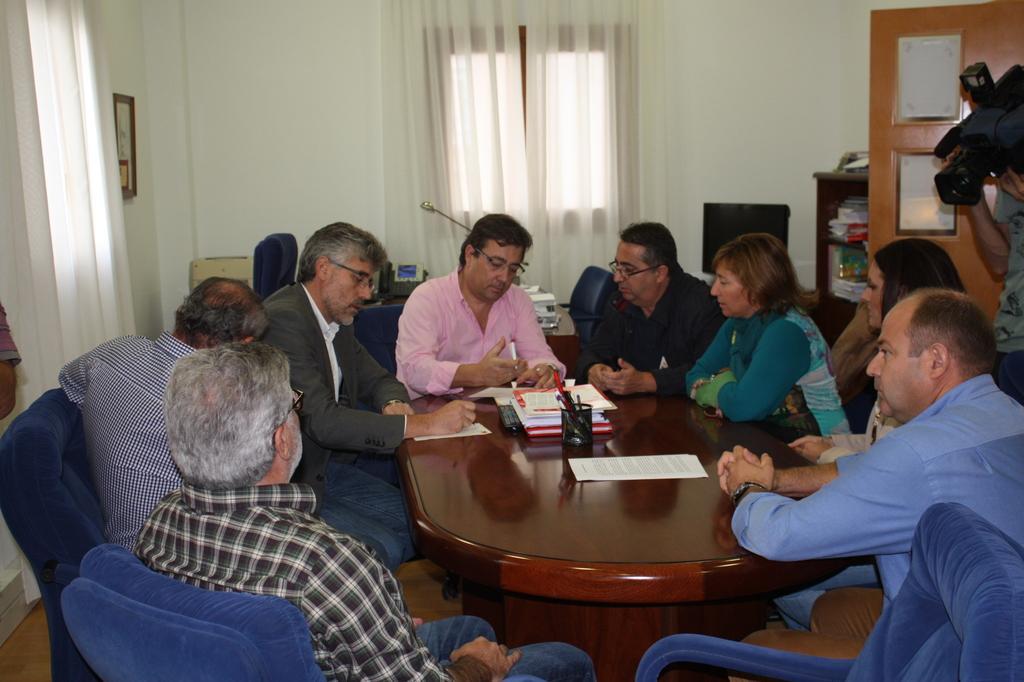How would you summarize this image in a sentence or two? A picture inside of a room. These persons are sitting on a chair. In-front of this person there is a table, on this table there are files, pen holder, remote and papers. This man is holding a pen. This man is standing and holding a camera. This rack is filled with books. On this table there are books, telephone and monitor. A picture on wall. This is window with curtain. 